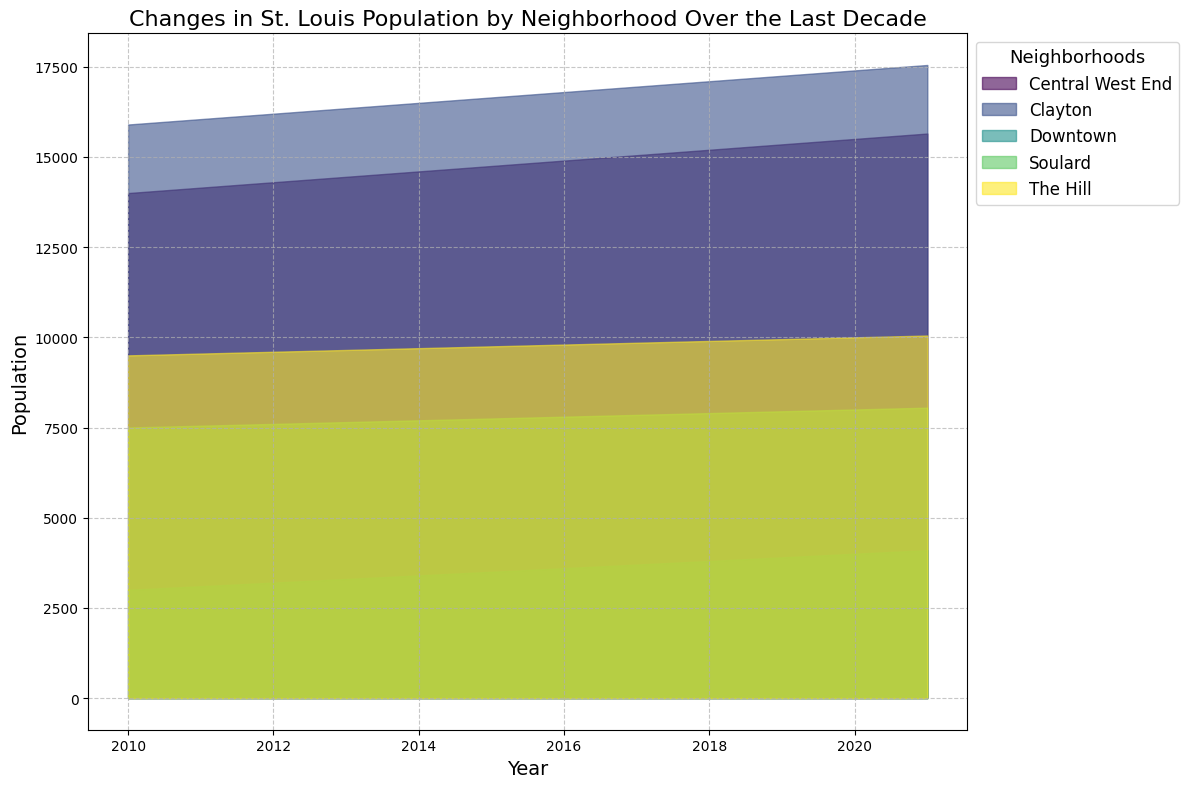How has the population of Downtown changed over the last decade? Observe the area section corresponding to Downtown. Starting in 2010 at 3000, the Downtown population has increased steadily each year, reaching 4100 by 2021.
Answer: Increased Which neighborhood shows the highest population growth from 2010 to 2021? Look at the difference in the area size for all neighborhoods between 2010 and 2021. Clayton appears to have the highest increase in population since it grew from 15900 in 2010 to 17550 in 2021.
Answer: Clayton Compare the population trends of Soulard and The Hill from 2010 to 2021. Examine the shape and slope of the areas for both neighborhoods. Both Soulard and The Hill show a steady increase over the years. However, The Hill starts at 9500 and grows to 10050, while Soulard starts at 7500 and increases to 8050, indicating similar trends but different starting populations.
Answer: Both increased steadily What is the range of population change for Central West End from 2010 to 2021? Calculate the initial and final populations for Central West End: from 14000 in 2010 to 15650 in 2021. The range is 15650 - 14000 = 1650.
Answer: 1650 Which neighborhood had the smallest population in 2010 and how does it compare to its population in 2021? Look at the smallest populated area in 2010, which is Downtown at 3000. In 2021, Downtown's population is 4100. This indicates an increase.
Answer: Downtown; increased to 4100 Identify the neighborhood with the most gradual population growth from 2010 to 2021. Compare the slopes of the areas for all neighborhoods. Soulard shows the most gradual population growth, increasing from 7500 in 2010 to 8050 in 2021, which is the least change among all neighborhoods.
Answer: Soulard By how much did the population of Clayton increase between 2010 and 2021? Identify the populations of Clayton for 2010 and 2021: from 15900 in 2010 to 17550 in 2021. The increase is 17550 - 15900 = 1650.
Answer: 1650 What can you infer about the trend in population growth across all neighborhoods? Generally, each neighborhood demonstrates a steady increase in population over the last decade. This indicates a positive trend in population growth throughout St. Louis neighborhoods.
Answer: Steady increase 